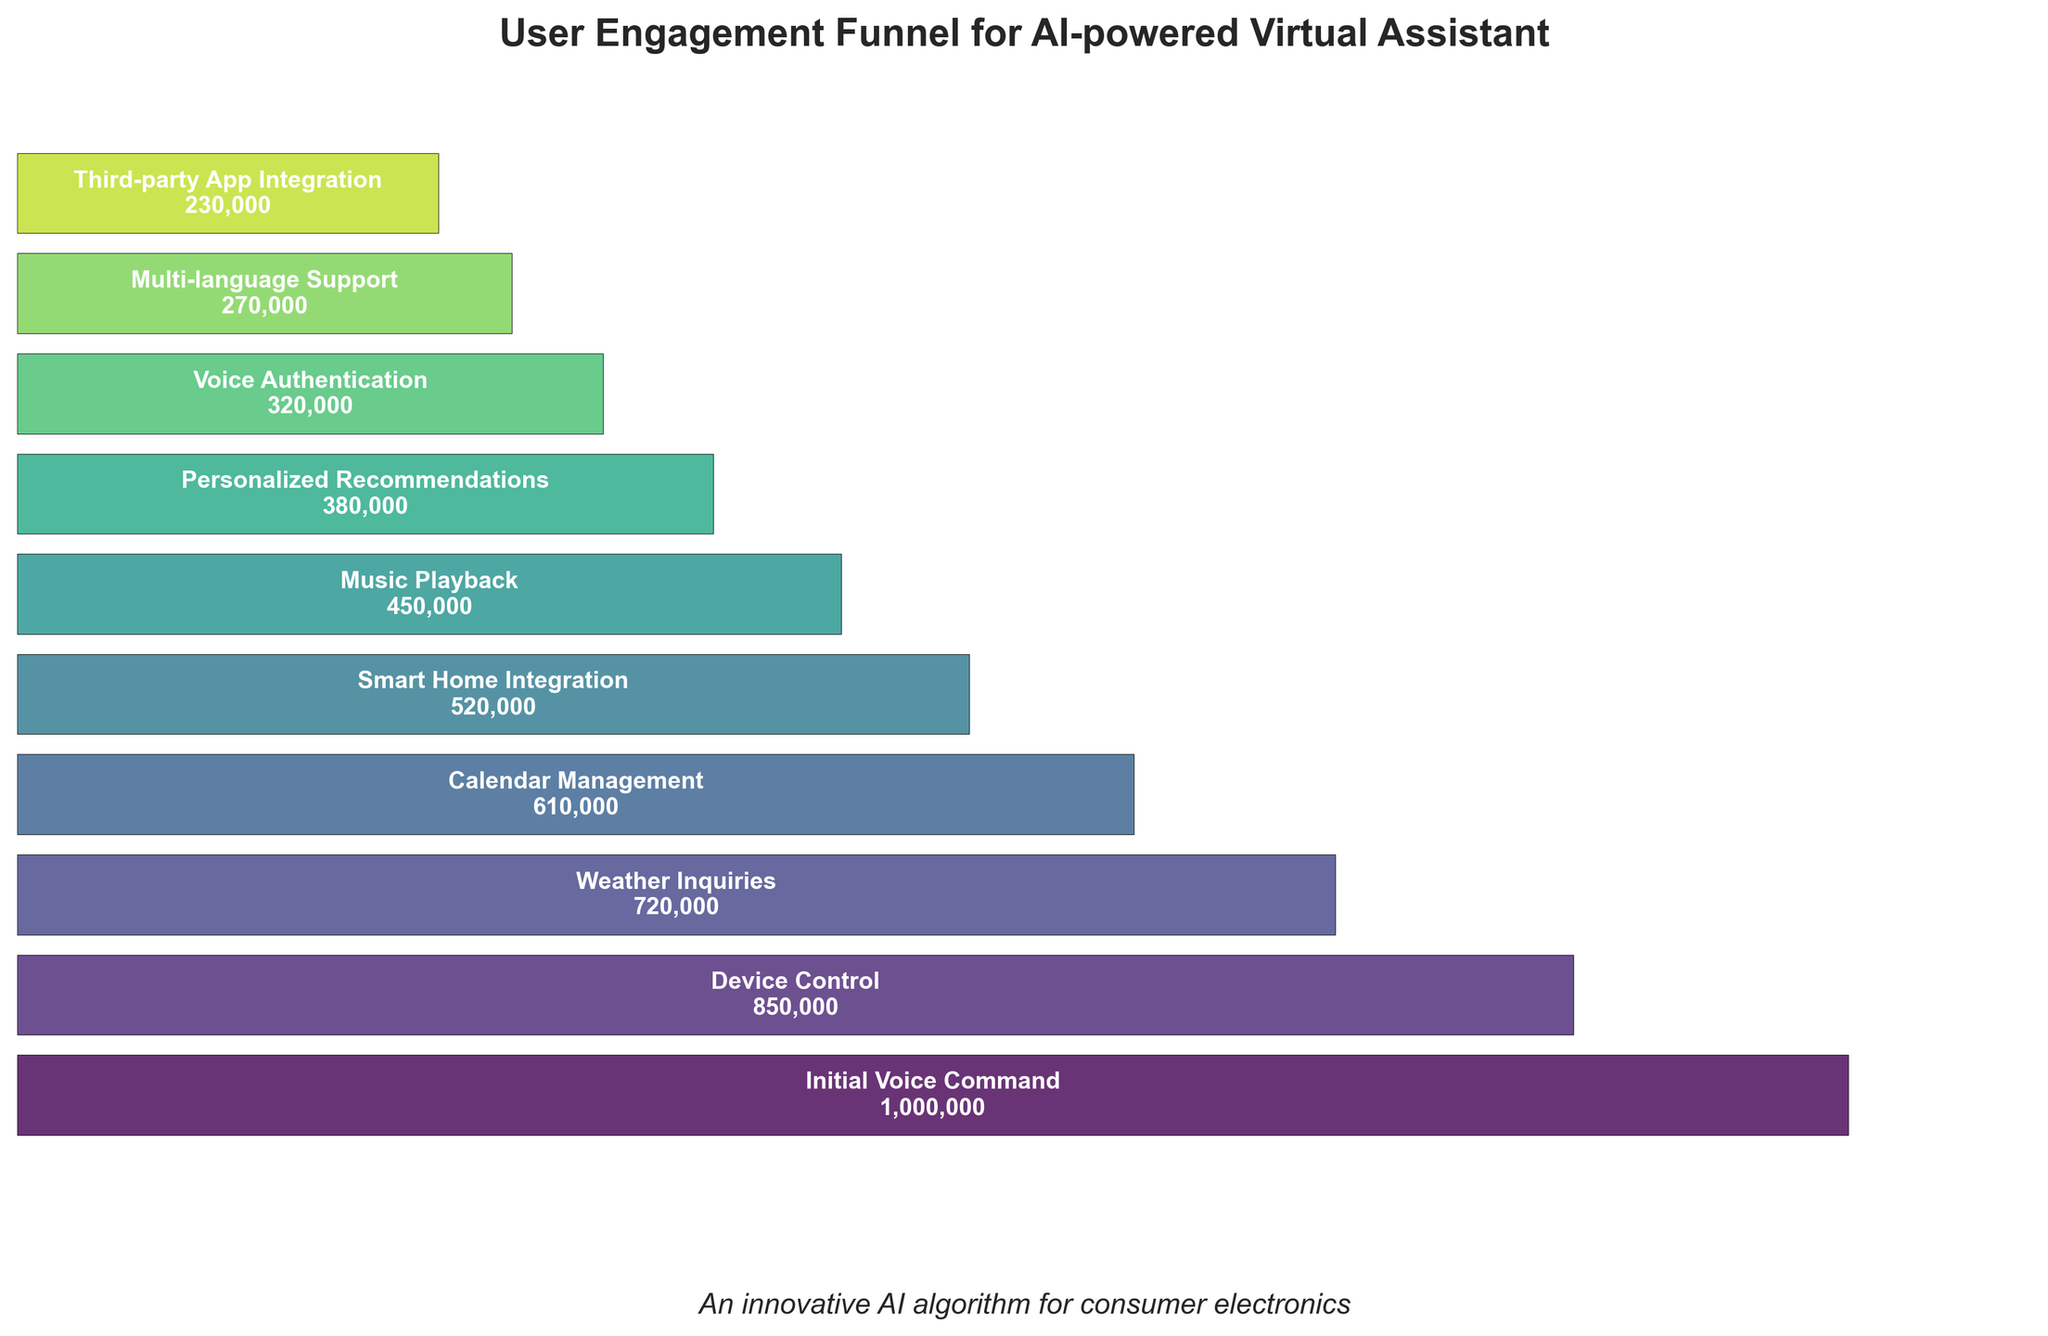What's the title of the figure? The title of the figure is always found at the top of the chart. In this case, it reads 'User Engagement Funnel for AI-powered Virtual Assistant'.
Answer: User Engagement Funnel for AI-powered Virtual Assistant Which feature has the highest number of users? The highest number of users can be identified as the widest point at the top of the funnel. Here, 'Initial Voice Command' has the most users, with 1,000,000.
Answer: Initial Voice Command Which feature has the smallest number of users? The smallest number of users can be identified as the narrowest point at the bottom of the funnel. In this case, 'Third-party App Integration' has the fewest users, with 230,000.
Answer: Third-party App Integration What's the difference in the number of users between 'Device Control' and 'Multi-language Support'? To find the difference, subtract the number of users of 'Multi-language Support' from 'Device Control'. 'Device Control' has 850,000 users and 'Multi-language Support' has 270,000 users. 850,000 - 270,000 = 580,000.
Answer: 580,000 What's the average number of users across all features? To find the average, sum all the user counts and divide by the number of features. The sum is 1000000 + 850000 + 720000 + 610000 + 520000 + 450000 + 380000 + 320000 + 270000 + 230000 = 5350000. There are 10 features. 5350000 / 10 = 535,000.
Answer: 535,000 How many features have fewer than 500,000 users? Count all features with user counts below 500,000. They are 'Music Playback' (450,000), 'Personalized Recommendations' (380,000), 'Voice Authentication' (320,000), 'Multi-language Support' (270,000), and 'Third-party App Integration' (230,000). There are 5 such features.
Answer: 5 Are there more users for 'Calendar Management' or 'Weather Inquiries'? Compare the number of users for both features. 'Weather Inquiries' has 720,000 users while 'Calendar Management' has 610,000 users.
Answer: Weather Inquiries What percentage of users from 'Initial Voice Command' move to 'Device Control'? To find the percentage, divide the number of users of 'Device Control' by 'Initial Voice Command' and multiply by 100. (850,000 / 1,000,000) * 100 = 85%.
Answer: 85% What's the cumulative number of users from 'Smart Home Integration' to 'Third-party App Integration'? Add the number of users for each feature from 'Smart Home Integration' to 'Third-party App Integration'. 520,000 + 450,000 + 380,000 + 320,000 + 270,000 + 230,000 = 2,170,000.
Answer: 2,170,000 Which feature has exactly half the users of 'Initial Voice Command'? Find which feature has half the number of users of 'Initial Voice Command'. Half of 1,000,000 is 500,000. 'Smart Home Integration' has 520,000 users, the closest amount.
Answer: Smart Home Integration 